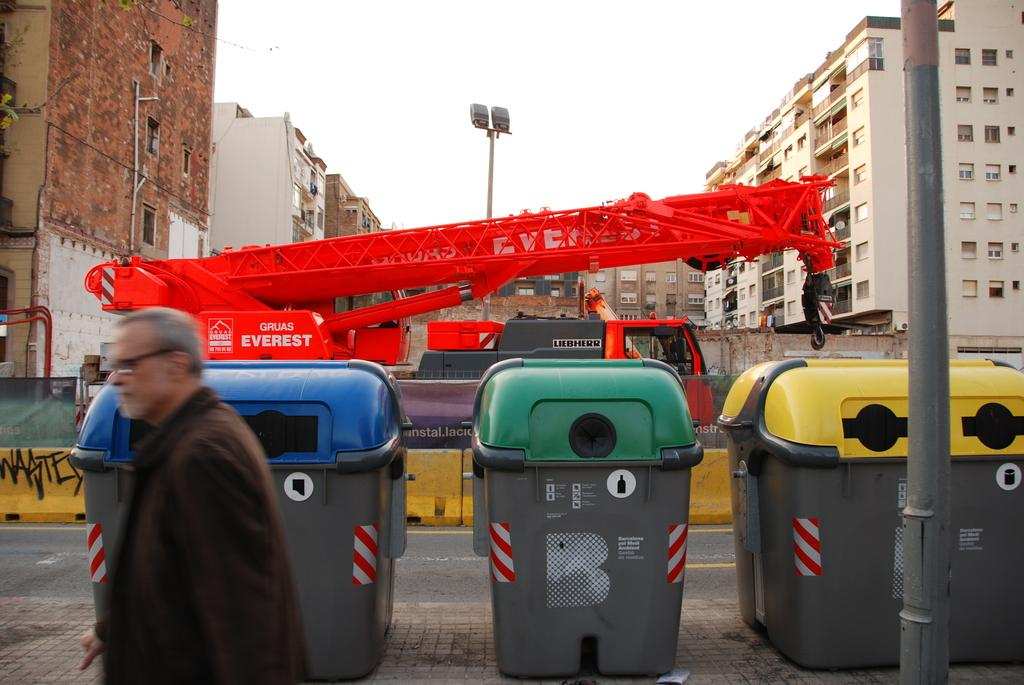<image>
Create a compact narrative representing the image presented. A red crane truck that says Gruas Everest on the side is in a construction site. 